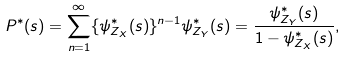<formula> <loc_0><loc_0><loc_500><loc_500>P ^ { * } ( s ) = \sum _ { n = 1 } ^ { \infty } \{ \psi _ { Z _ { X } } ^ { * } ( s ) \} ^ { n - 1 } \psi _ { Z _ { Y } } ^ { * } ( s ) = \frac { \psi _ { Z _ { Y } } ^ { * } ( s ) } { 1 - \psi _ { Z _ { X } } ^ { * } ( s ) } ,</formula> 